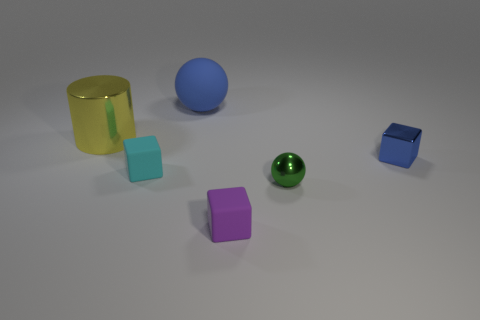Subtract all shiny blocks. How many blocks are left? 2 Subtract 1 spheres. How many spheres are left? 1 Add 2 cylinders. How many objects exist? 8 Subtract all green spheres. How many spheres are left? 1 Subtract all cylinders. How many objects are left? 5 Subtract all tiny purple objects. Subtract all large blue metallic balls. How many objects are left? 5 Add 5 tiny blue cubes. How many tiny blue cubes are left? 6 Add 4 big brown blocks. How many big brown blocks exist? 4 Subtract 0 yellow spheres. How many objects are left? 6 Subtract all blue cylinders. Subtract all brown spheres. How many cylinders are left? 1 